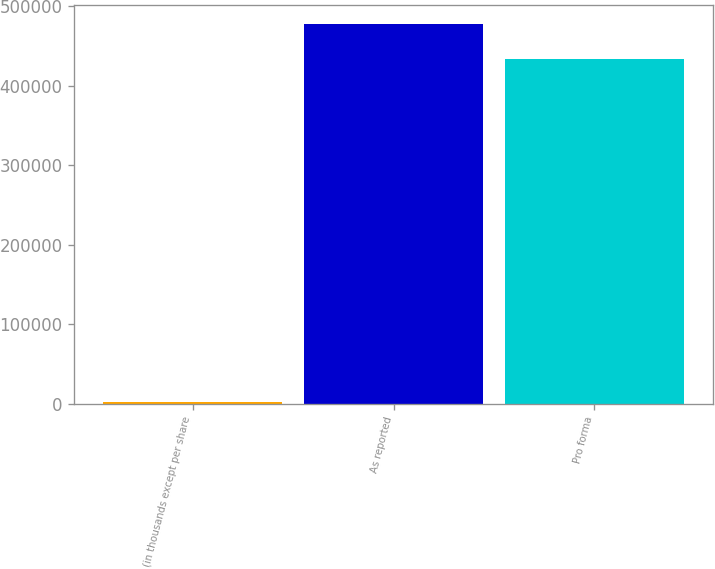Convert chart. <chart><loc_0><loc_0><loc_500><loc_500><bar_chart><fcel>(in thousands except per share<fcel>As reported<fcel>Pro forma<nl><fcel>2003<fcel>477537<fcel>433431<nl></chart> 